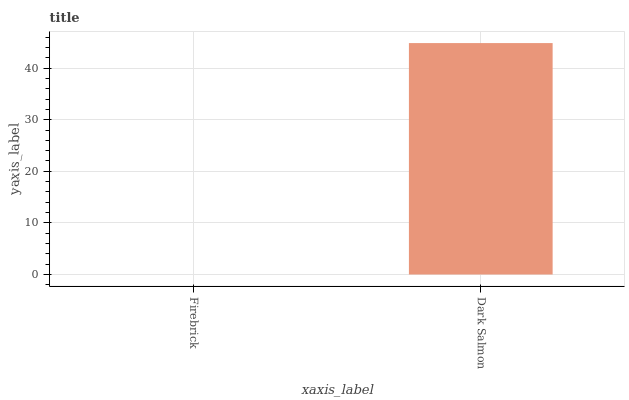Is Firebrick the minimum?
Answer yes or no. Yes. Is Dark Salmon the maximum?
Answer yes or no. Yes. Is Dark Salmon the minimum?
Answer yes or no. No. Is Dark Salmon greater than Firebrick?
Answer yes or no. Yes. Is Firebrick less than Dark Salmon?
Answer yes or no. Yes. Is Firebrick greater than Dark Salmon?
Answer yes or no. No. Is Dark Salmon less than Firebrick?
Answer yes or no. No. Is Dark Salmon the high median?
Answer yes or no. Yes. Is Firebrick the low median?
Answer yes or no. Yes. Is Firebrick the high median?
Answer yes or no. No. Is Dark Salmon the low median?
Answer yes or no. No. 